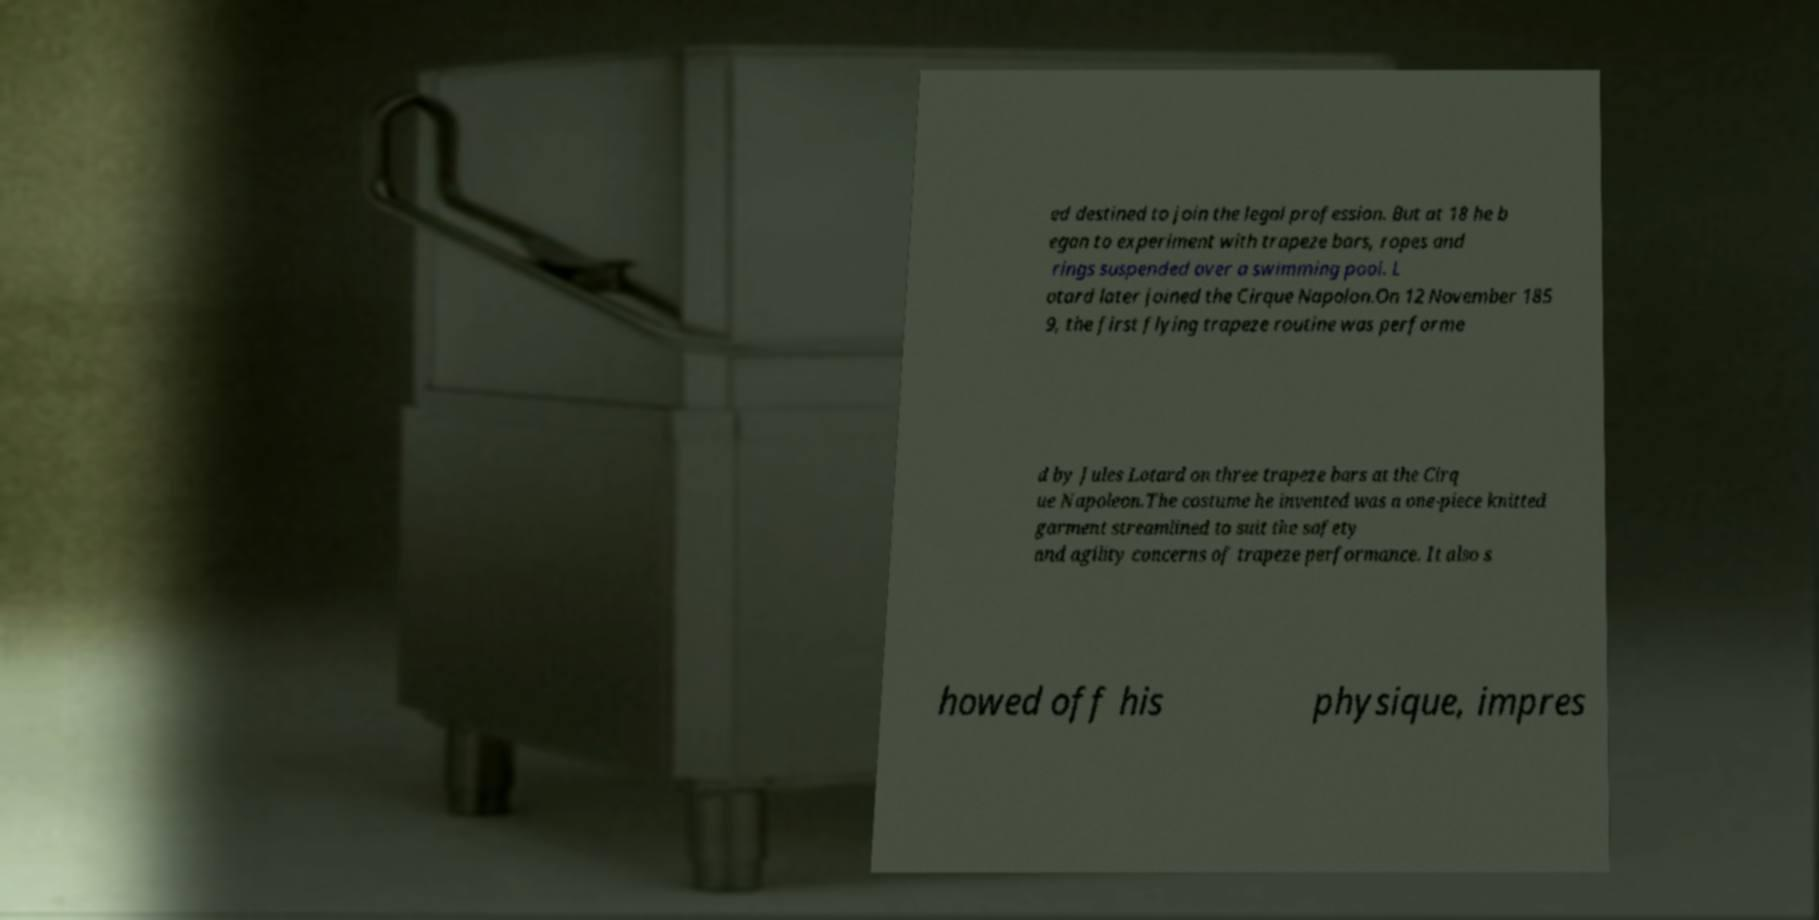Could you extract and type out the text from this image? ed destined to join the legal profession. But at 18 he b egan to experiment with trapeze bars, ropes and rings suspended over a swimming pool. L otard later joined the Cirque Napolon.On 12 November 185 9, the first flying trapeze routine was performe d by Jules Lotard on three trapeze bars at the Cirq ue Napoleon.The costume he invented was a one-piece knitted garment streamlined to suit the safety and agility concerns of trapeze performance. It also s howed off his physique, impres 